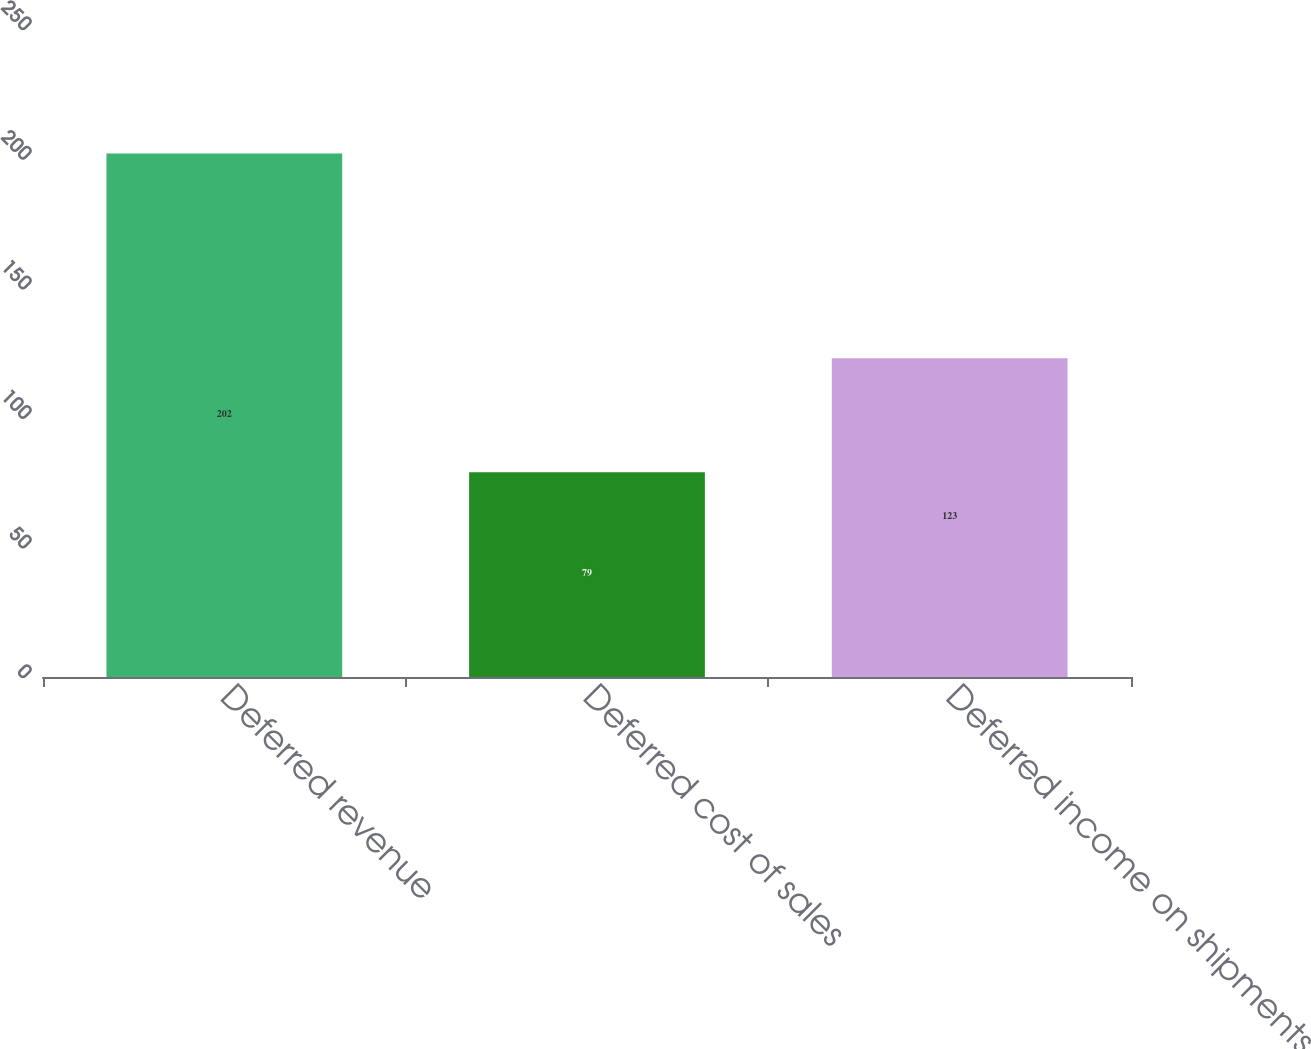Convert chart. <chart><loc_0><loc_0><loc_500><loc_500><bar_chart><fcel>Deferred revenue<fcel>Deferred cost of sales<fcel>Deferred income on shipments<nl><fcel>202<fcel>79<fcel>123<nl></chart> 